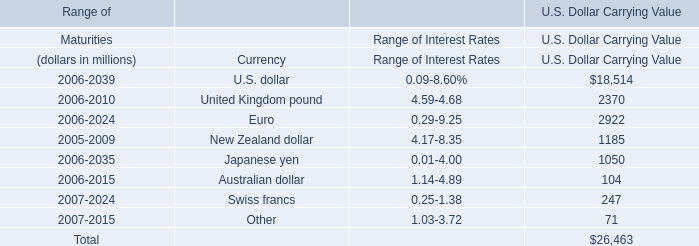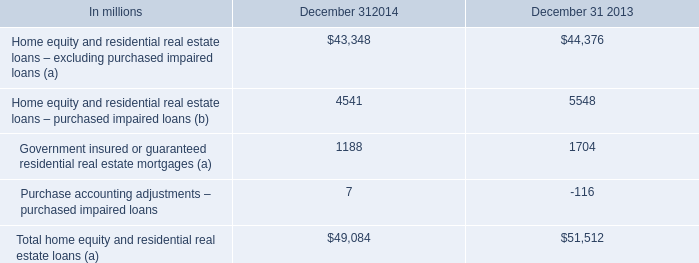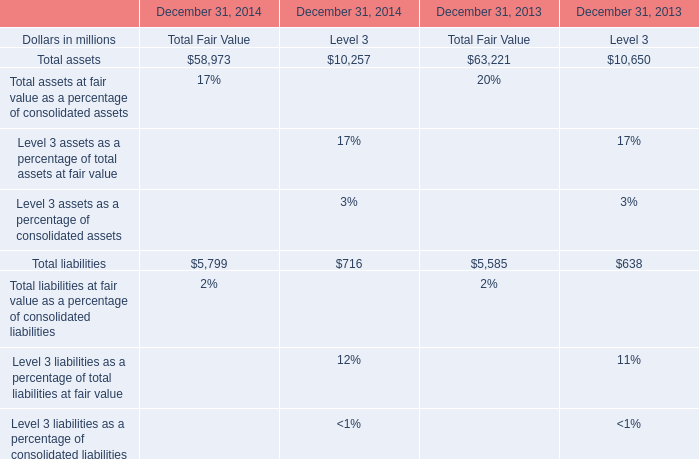What was the total amount of the Total liabilities in the sections where Total assets is greater than 11000 ? (in million) 
Computations: (5799 + 5585)
Answer: 11384.0. 